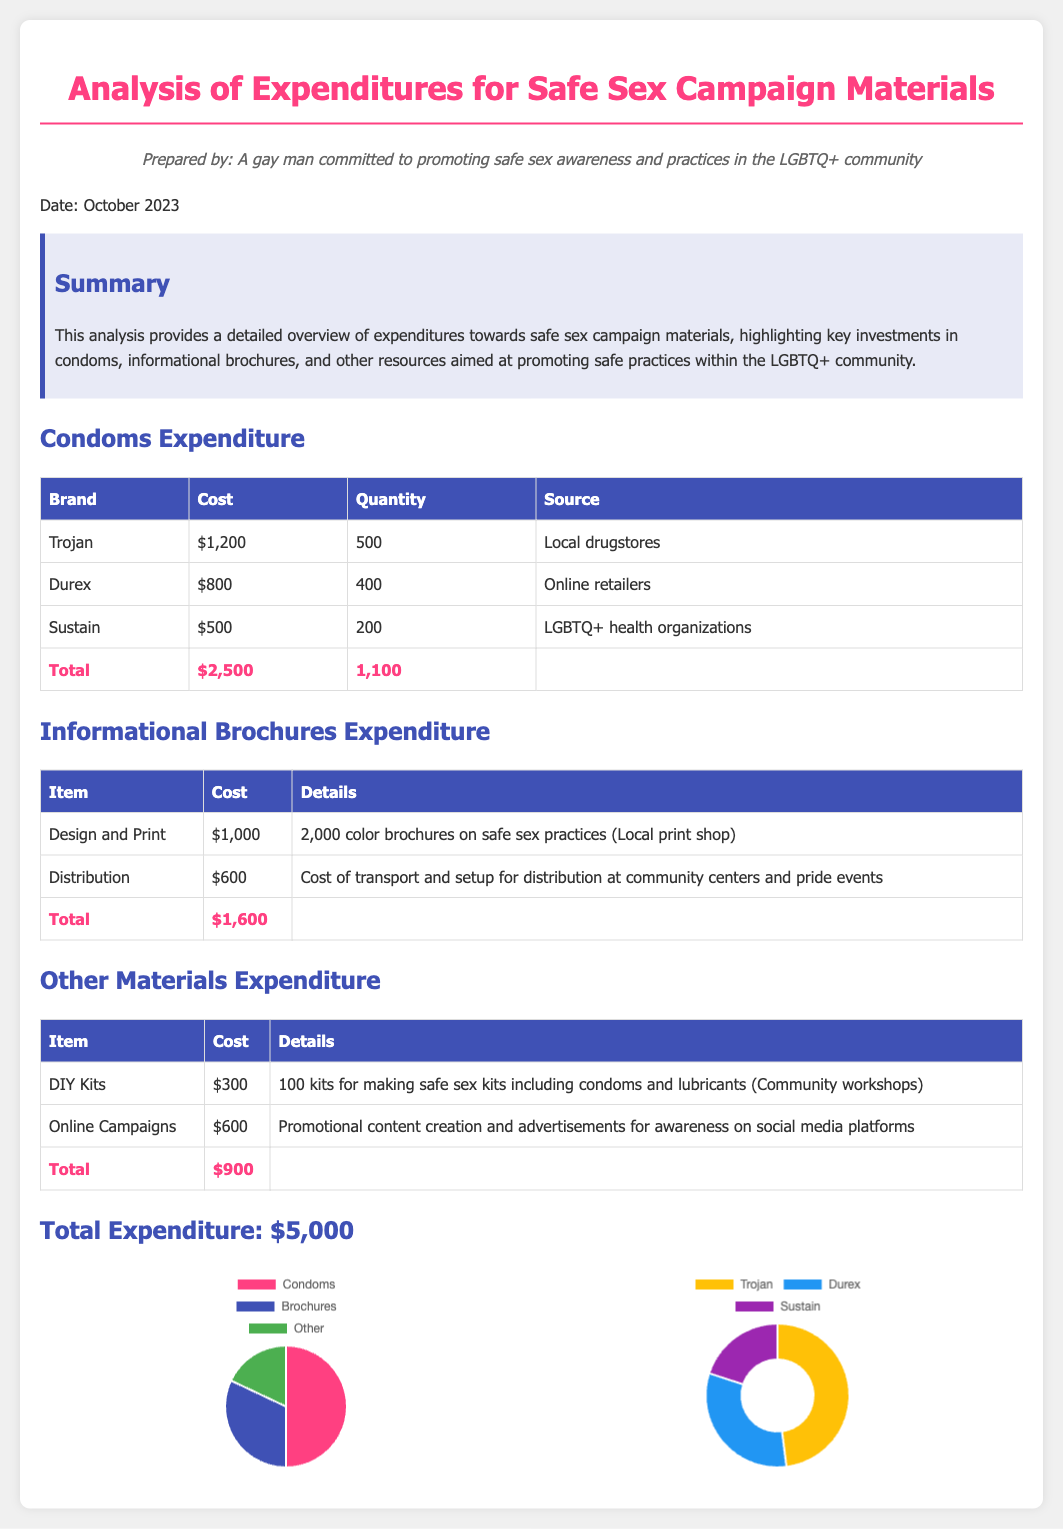What is the total expenditure? The total expenditure is stated at the end of the document, which totals all expenditure categories.
Answer: $5,000 How much was spent on condoms? The expenditure section specifically outlines the total cost for condoms.
Answer: $2,500 What is the cost of design and print for brochures? This is detailed under the Informational Brochures Expenditure section.
Answer: $1,000 Which brand spent the least on condoms? This requires comparing the costs of each brand listed in the expenditures.
Answer: Sustain What is the total quantity of condoms purchased? This is provided in the table summarizing condom expenditure.
Answer: 1,100 How much was allocated to distribution of brochures? This figure is specifically mentioned in the Informational Brochures Expenditure section.
Answer: $600 What percentage of total expenditure was spent on brochures? This requires calculating based on the total expenditure and brochure expenditure.
Answer: 32% Which source provided the Sustain condoms? Each entry has a source listed, specifically for the Sustain condoms.
Answer: LGBTQ+ health organizations What two types of materials are included in the expenditures? The categories for expenditure are listed at the beginning of each section.
Answer: Condoms and Informational Brochures 